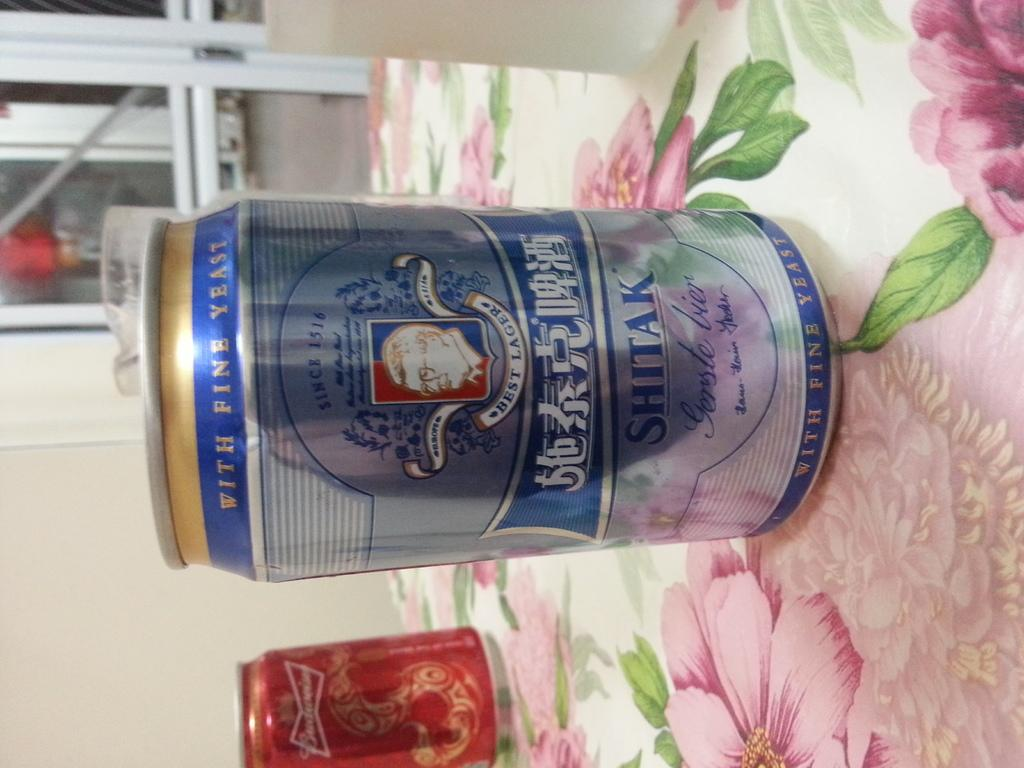Provide a one-sentence caption for the provided image. A can of shitak lager is on the table with flower pattern cloth. 